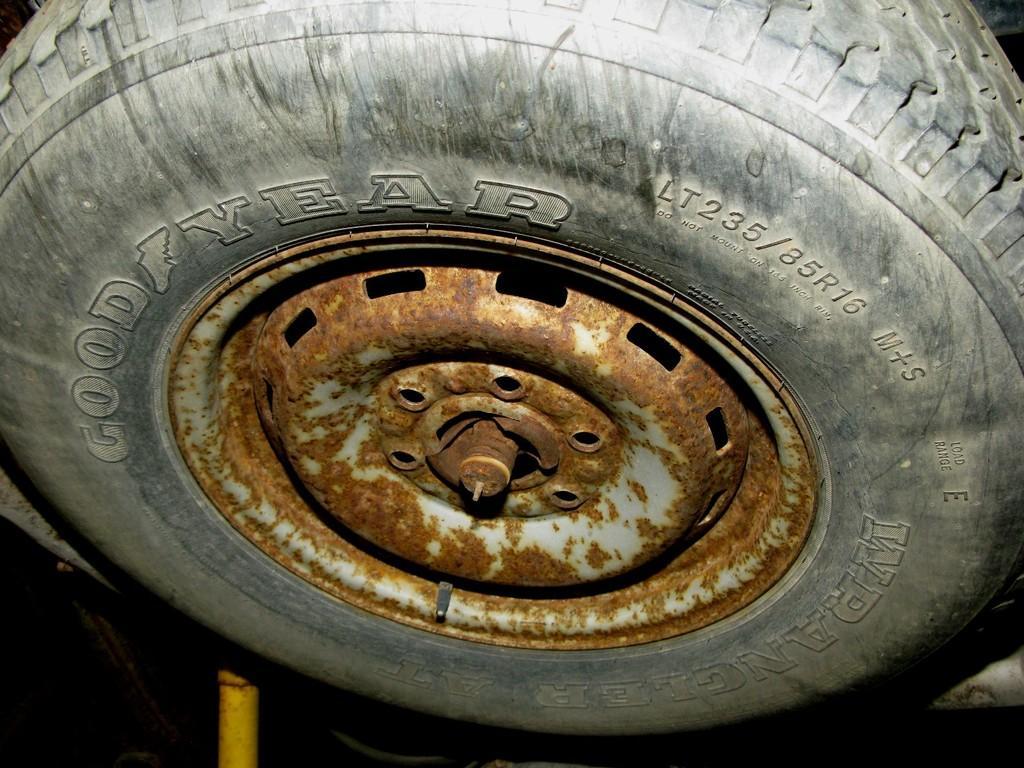Please provide a concise description of this image. In this image in the center there is a tyre, and on the tyre there is a text. And at the bottom there is a yellow color pole and there is a dark background. 